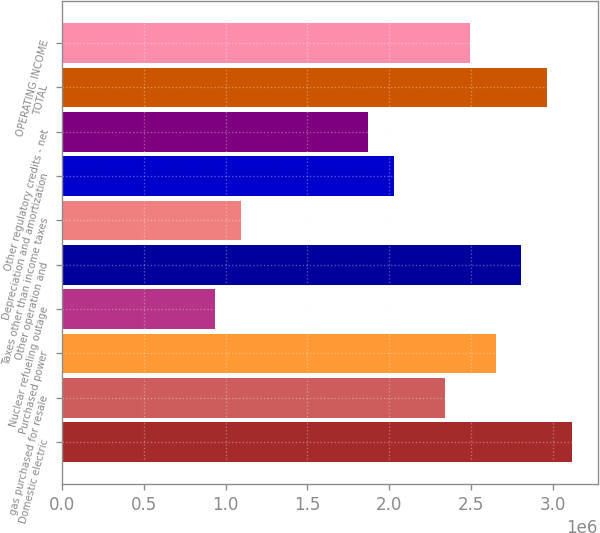Convert chart. <chart><loc_0><loc_0><loc_500><loc_500><bar_chart><fcel>Domestic electric<fcel>gas purchased for resale<fcel>Purchased power<fcel>Nuclear refueling outage<fcel>Other operation and<fcel>Taxes other than income taxes<fcel>Depreciation and amortization<fcel>Other regulatory credits - net<fcel>TOTAL<fcel>OPERATING INCOME<nl><fcel>3.11975e+06<fcel>2.34043e+06<fcel>2.65216e+06<fcel>937653<fcel>2.80802e+06<fcel>1.09352e+06<fcel>2.0287e+06<fcel>1.87284e+06<fcel>2.96389e+06<fcel>2.4963e+06<nl></chart> 